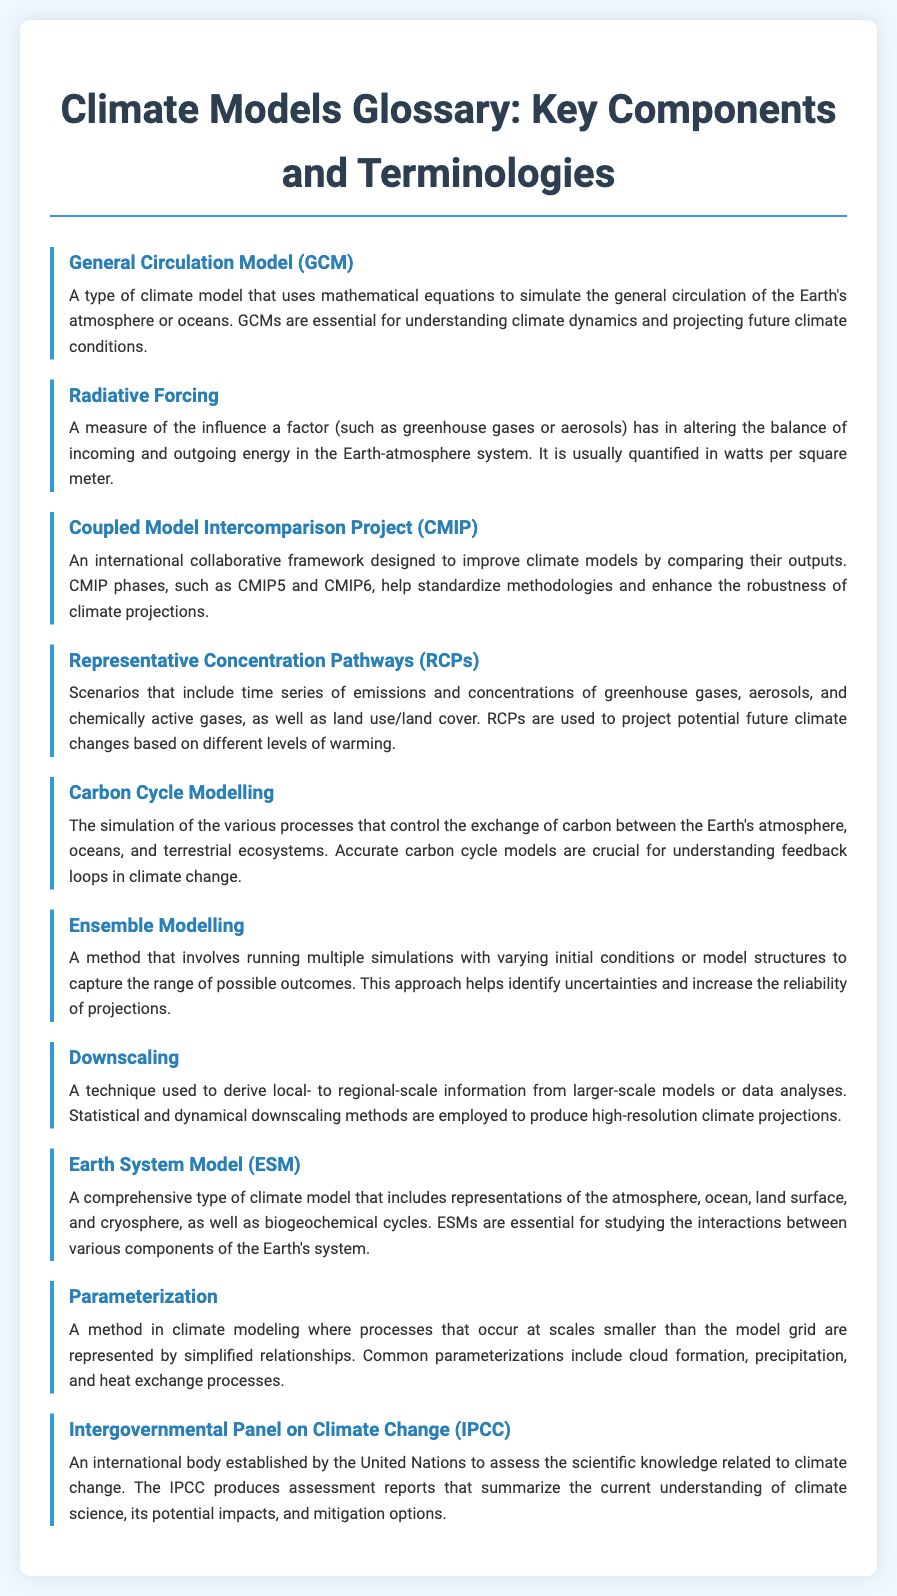what is a General Circulation Model? A General Circulation Model is defined in the glossary as a type of climate model that uses mathematical equations to simulate the general circulation of the Earth's atmosphere or oceans.
Answer: A type of climate model that uses mathematical equations to simulate the general circulation of the Earth's atmosphere or oceans what does Radiative Forcing measure? Radiative Forcing measures the influence a factor has in altering the balance of incoming and outgoing energy in the Earth-atmosphere system, as mentioned in the definition.
Answer: Influence of a factor on energy balance what is the purpose of the Coupled Model Intercomparison Project? The Coupled Model Intercomparison Project is described in the glossary as a framework designed to improve climate models by comparing their outputs.
Answer: Improve climate models by comparing their outputs what scenarios do Representative Concentration Pathways include? The glossary states that Representative Concentration Pathways include time series of emissions and concentrations of greenhouse gases, aerosols, and chemically active gases.
Answer: Emissions and concentrations of greenhouse gases what is the significance of Carbon Cycle Modelling? The definition states that Carbon Cycle Modelling is crucial for understanding feedback loops in climate change.
Answer: Understanding feedback loops in climate change how does Ensemble Modelling increase reliability? Ensemble Modelling involves running multiple simulations to capture the range of possible outcomes, enhancing reliability, as stated in the definition.
Answer: Capturing the range of possible outcomes what techniques are used in Downscaling? The glossary mentions statistical and dynamical methods are employed in Downscaling to produce high-resolution climate projections.
Answer: Statistical and dynamical methods what is an Earth System Model? An Earth System Model is defined as a comprehensive type of climate model that includes various representations of the Earth's system components.
Answer: Comprehensive climate model what does Parameterization represent? Parameterization in climate modeling represents processes that occur at scales smaller than the model grid through simplified relationships.
Answer: Processes at scales smaller than the model grid who established the Intergovernmental Panel on Climate Change? The glossary mentions that the Intergovernmental Panel on Climate Change was established by the United Nations.
Answer: The United Nations 